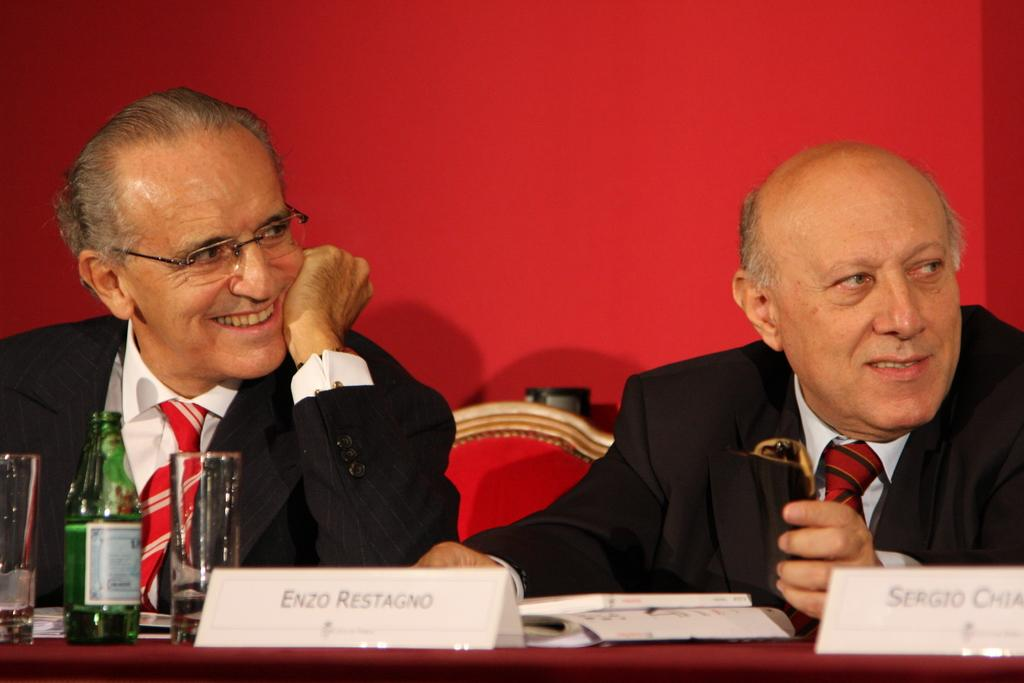What are the people in the image doing? The people in the image are sitting on chairs. What can be seen on the table in the image? There are many objects on the table in the image. What color is the background of the image? The background of the image is red. Is there a prison visible in the image? No, there is no prison present in the image. Can you see a stream flowing in the background of the image? No, there is no stream visible in the image; the background is red. 